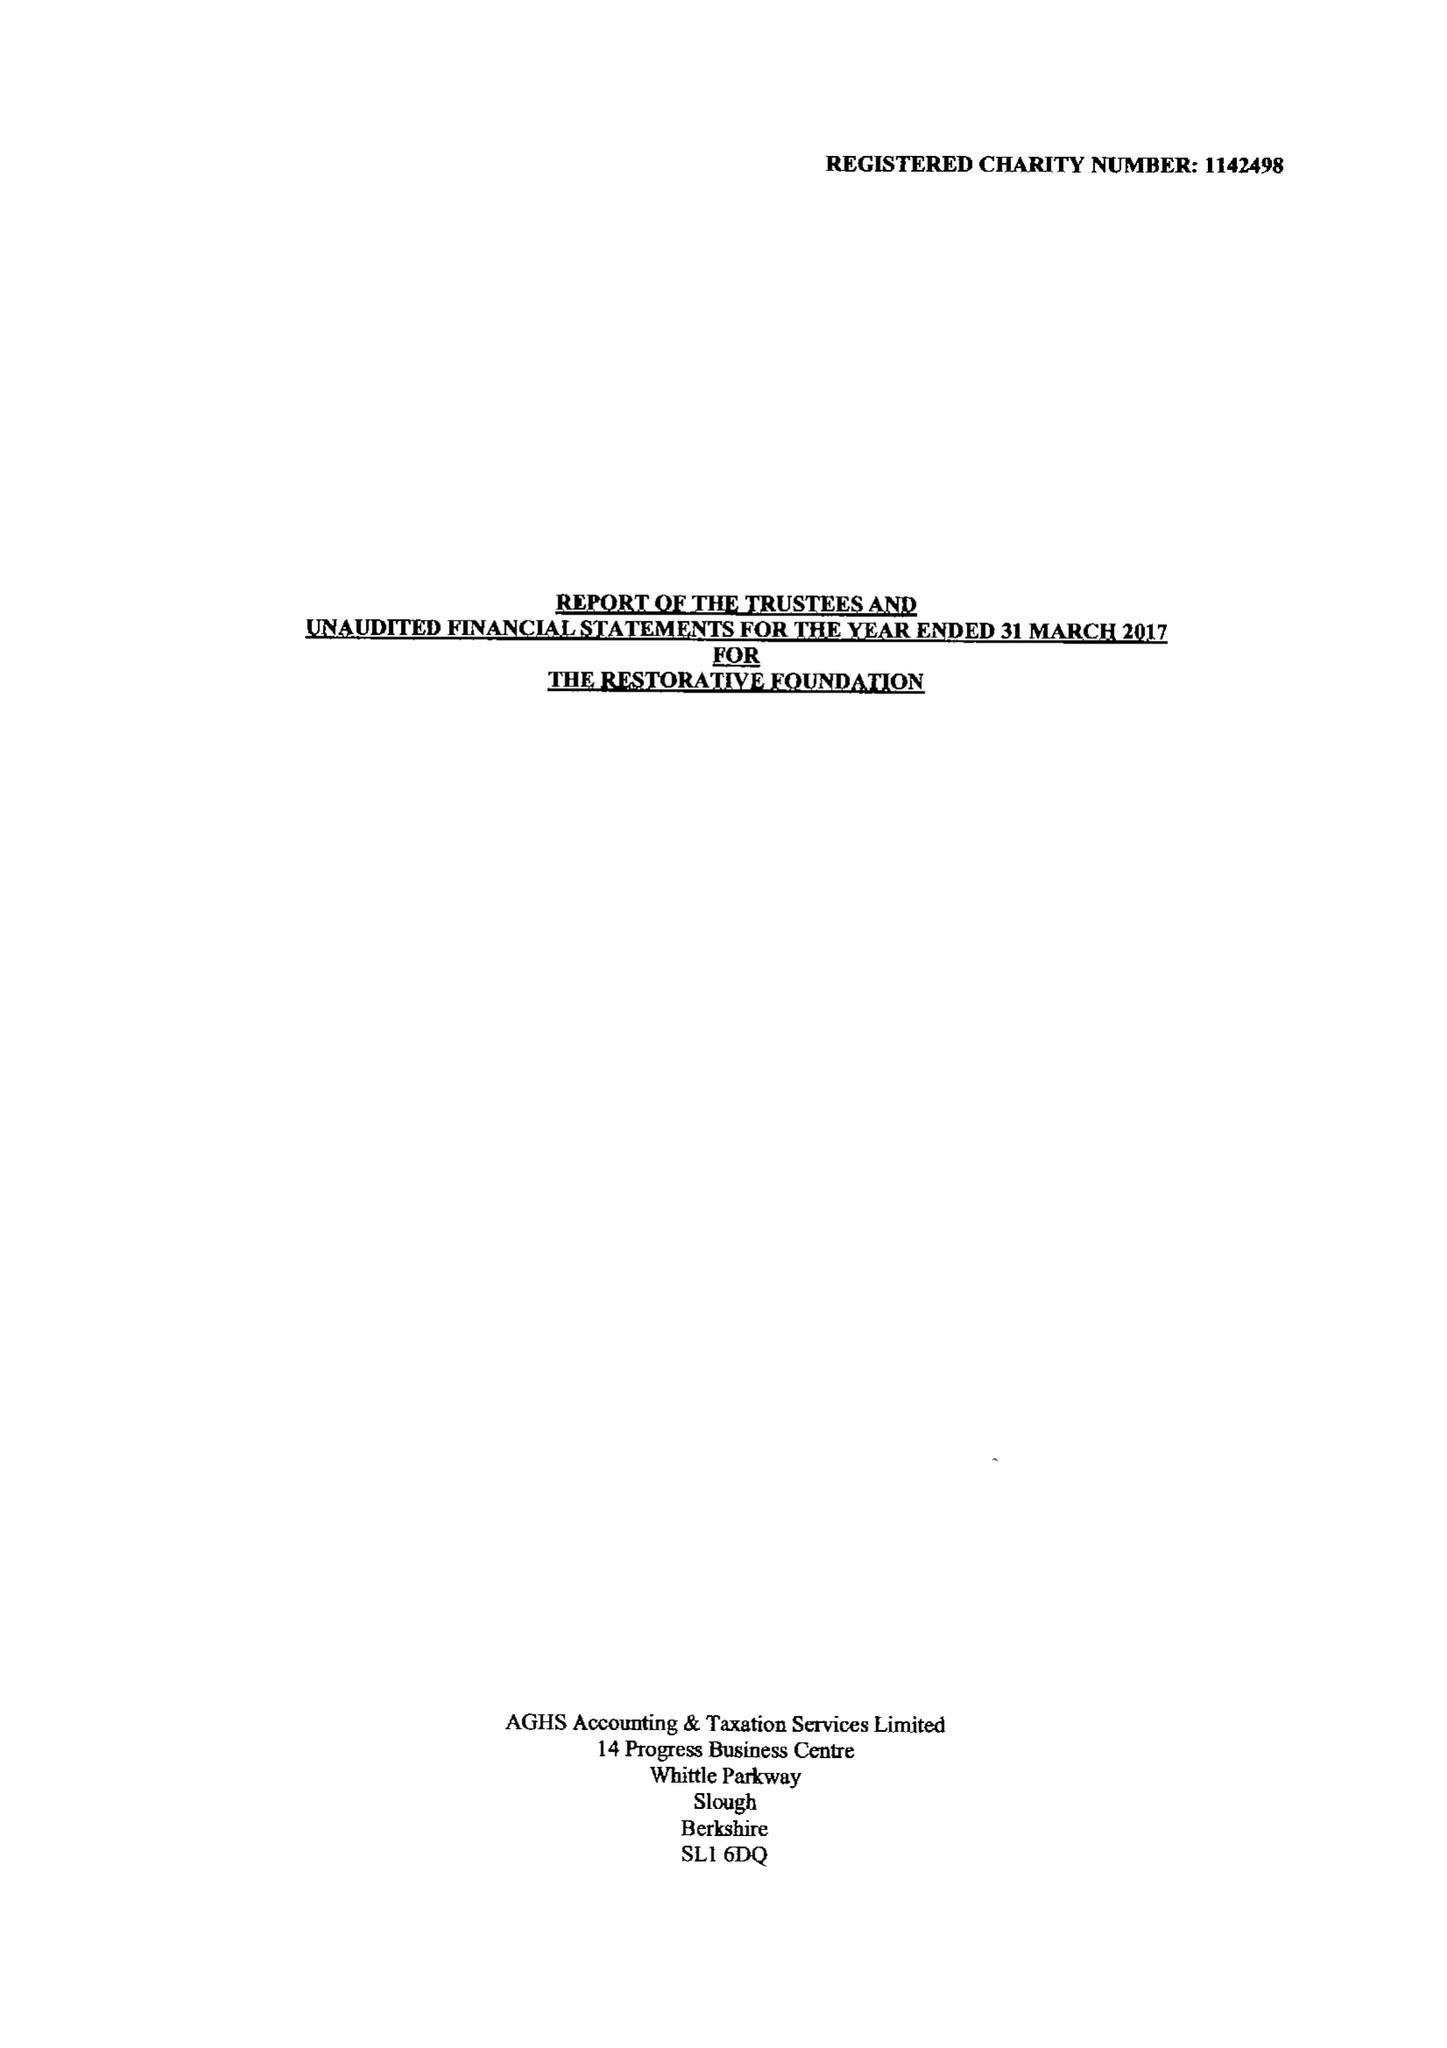What is the value for the address__post_town?
Answer the question using a single word or phrase. UXBRIDGE 